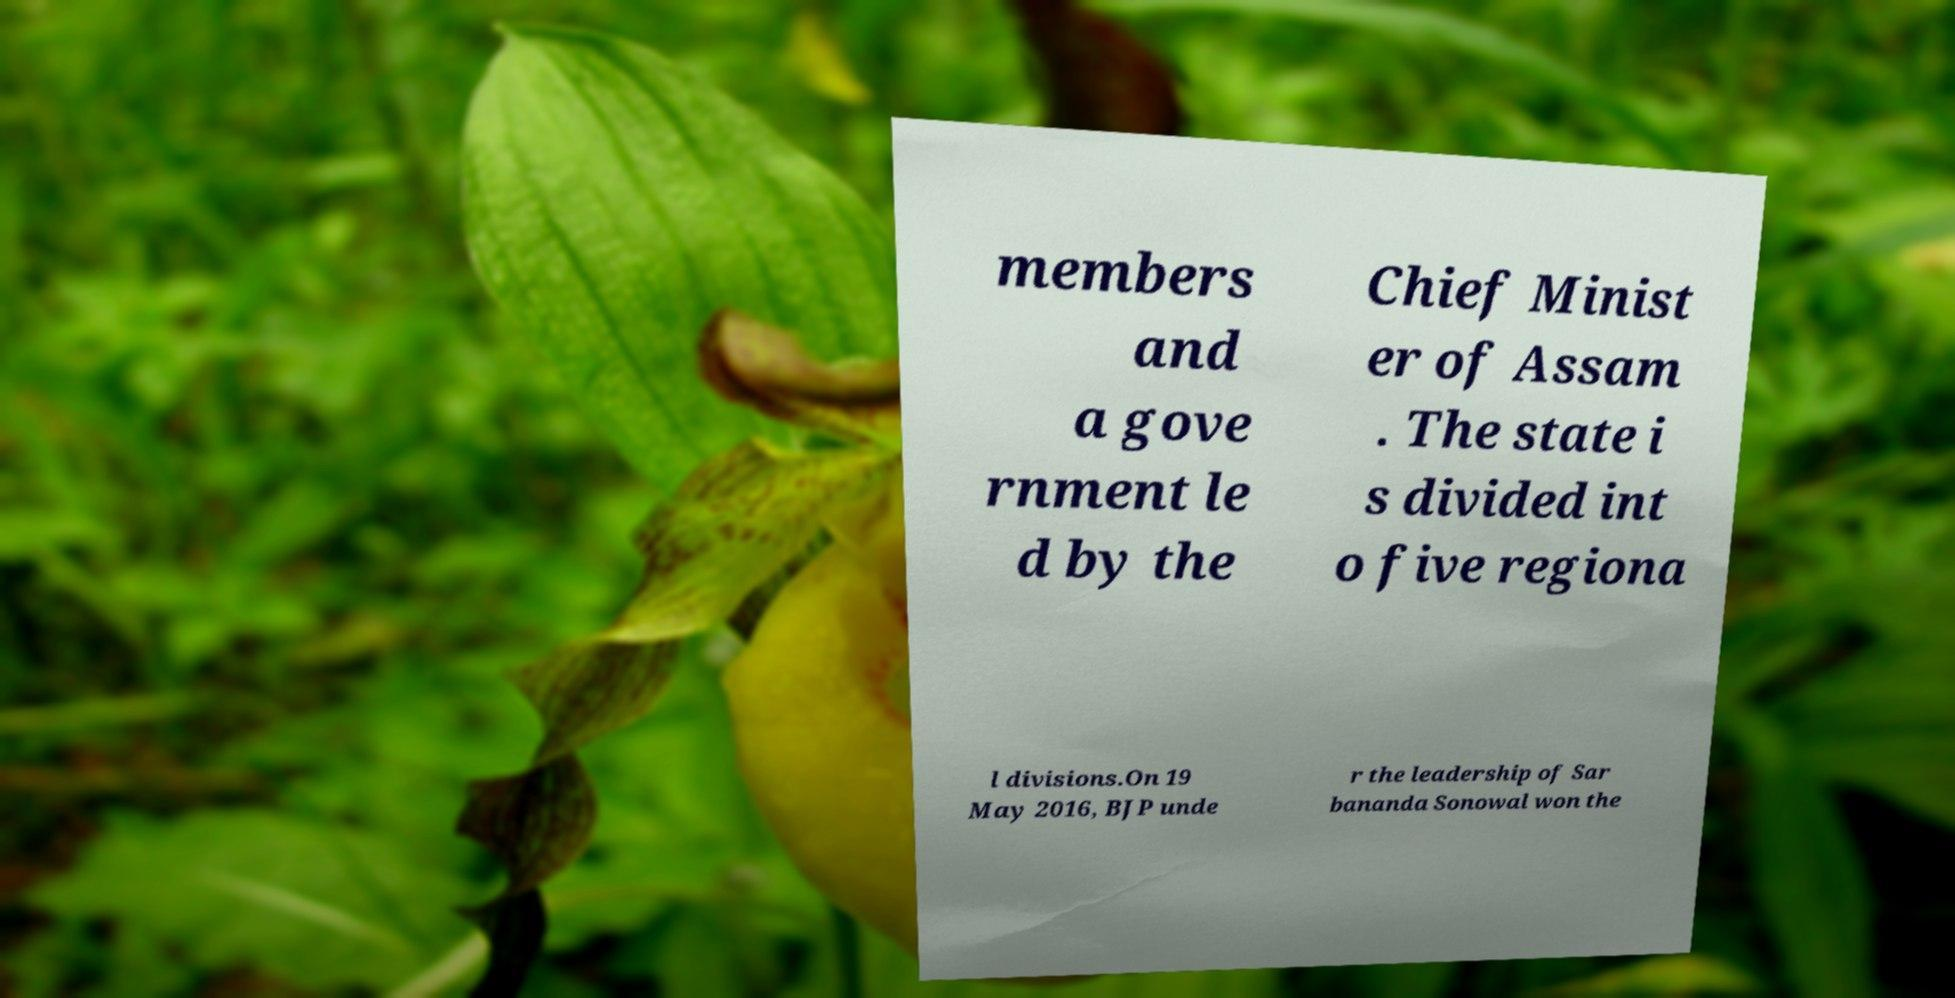Can you read and provide the text displayed in the image?This photo seems to have some interesting text. Can you extract and type it out for me? members and a gove rnment le d by the Chief Minist er of Assam . The state i s divided int o five regiona l divisions.On 19 May 2016, BJP unde r the leadership of Sar bananda Sonowal won the 